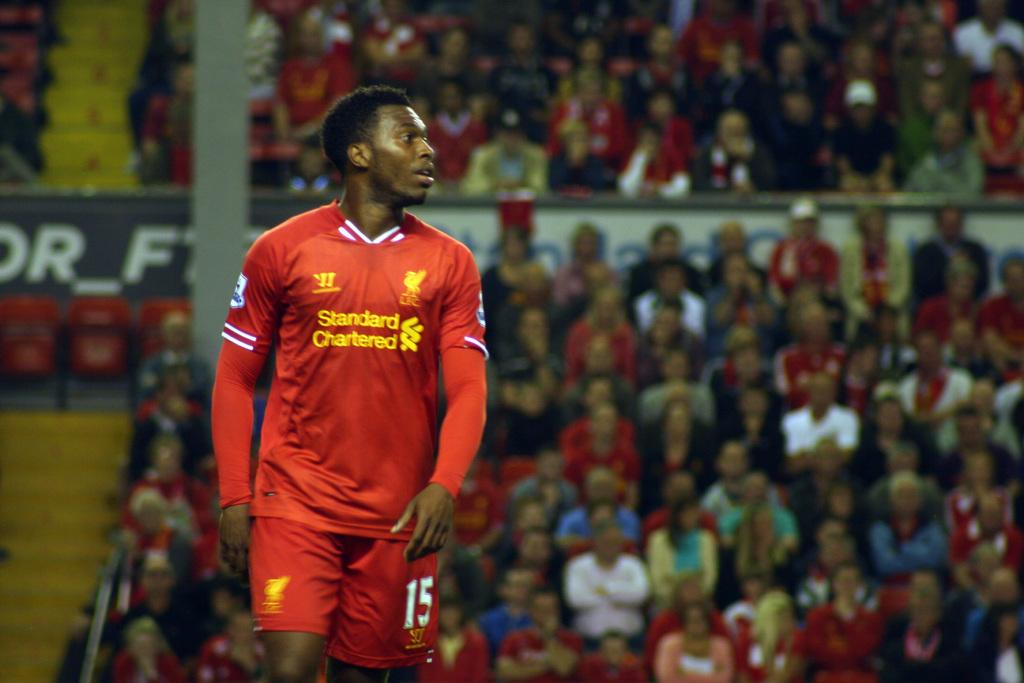<image>
Create a compact narrative representing the image presented. a soccr player that is wearing a Standard Chartered jersey 